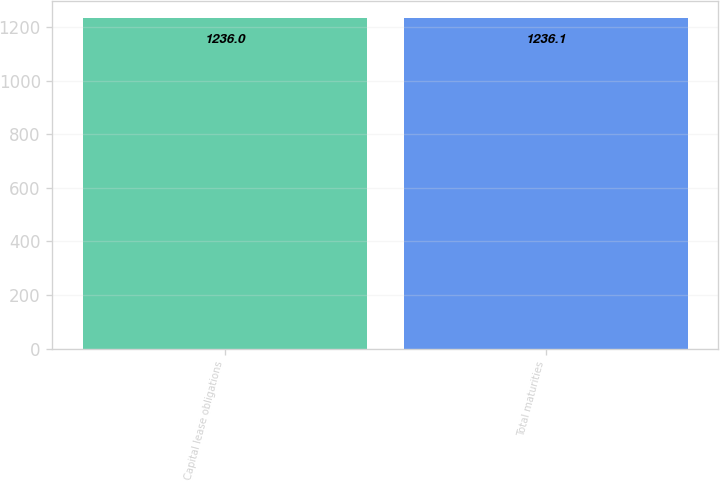<chart> <loc_0><loc_0><loc_500><loc_500><bar_chart><fcel>Capital lease obligations<fcel>Total maturities<nl><fcel>1236<fcel>1236.1<nl></chart> 